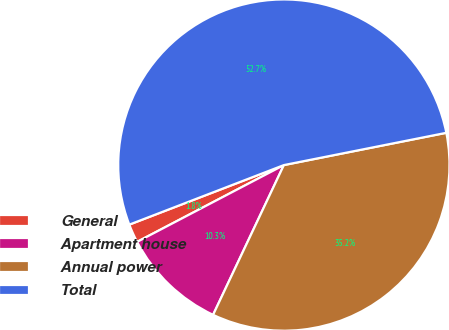Convert chart to OTSL. <chart><loc_0><loc_0><loc_500><loc_500><pie_chart><fcel>General<fcel>Apartment house<fcel>Annual power<fcel>Total<nl><fcel>1.82%<fcel>10.3%<fcel>35.15%<fcel>52.73%<nl></chart> 